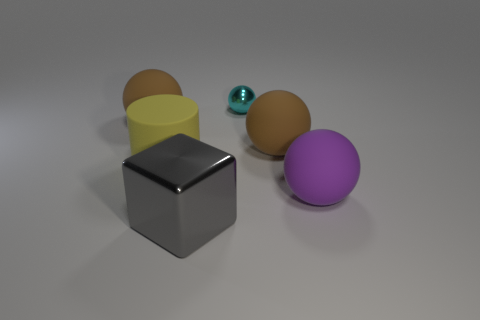How many other objects are the same shape as the purple matte thing?
Your answer should be very brief. 3. Is the shape of the yellow rubber object the same as the large brown rubber thing on the right side of the tiny cyan object?
Provide a short and direct response. No. Is there any other thing that has the same material as the gray block?
Ensure brevity in your answer.  Yes. There is a small thing that is the same shape as the large purple rubber thing; what is it made of?
Provide a short and direct response. Metal. How many small things are purple balls or gray metallic cubes?
Offer a terse response. 0. Is the number of yellow matte objects that are in front of the purple matte thing less than the number of large rubber balls left of the cyan thing?
Your answer should be very brief. Yes. How many things are either big cubes or large red blocks?
Offer a very short reply. 1. What number of large objects are in front of the big yellow rubber thing?
Offer a very short reply. 2. The other thing that is the same material as the small thing is what shape?
Your response must be concise. Cube. There is a brown rubber thing that is on the left side of the large gray metallic block; is it the same shape as the big purple object?
Your response must be concise. Yes. 